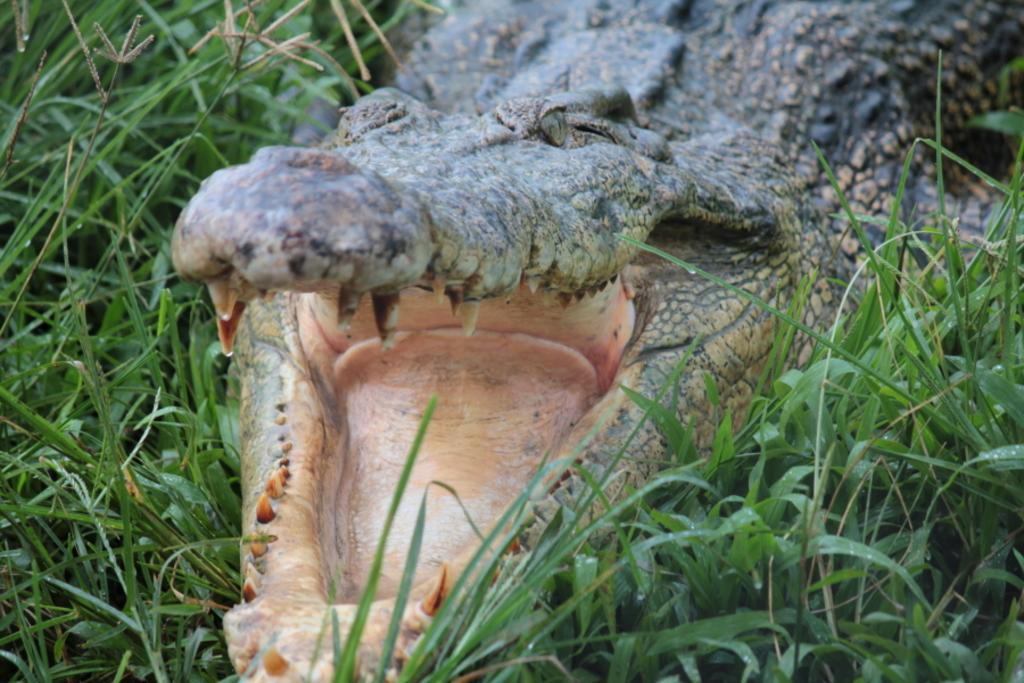What is the main subject in the center of the image? There is a crocodile in the center of the image. What type of vegetation can be seen in the image? There is grass in the image. What type of drawer is visible in the image? There is no drawer present in the image; it features a crocodile and grass. What discovery was made by the crocodile in the image? There is no indication of a discovery made by the crocodile in the image. 